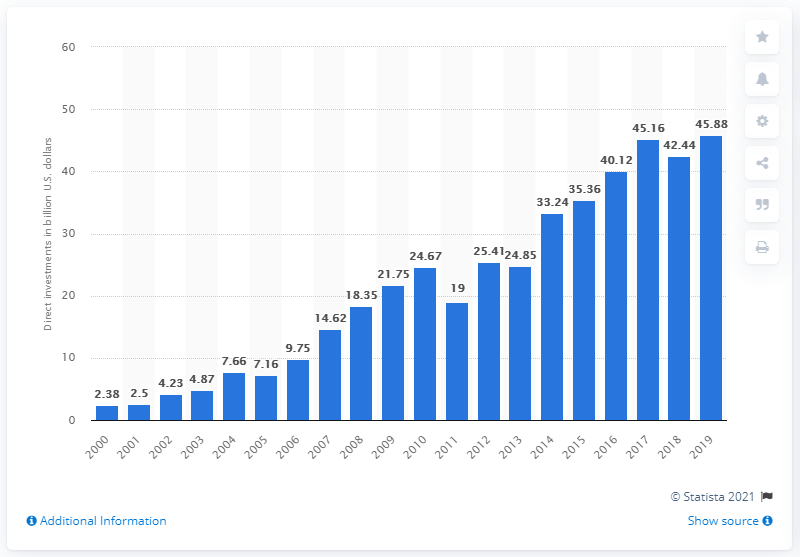Identify some key points in this picture. The value of U.S. investments made in India in 2019 was $45.88 billion. 